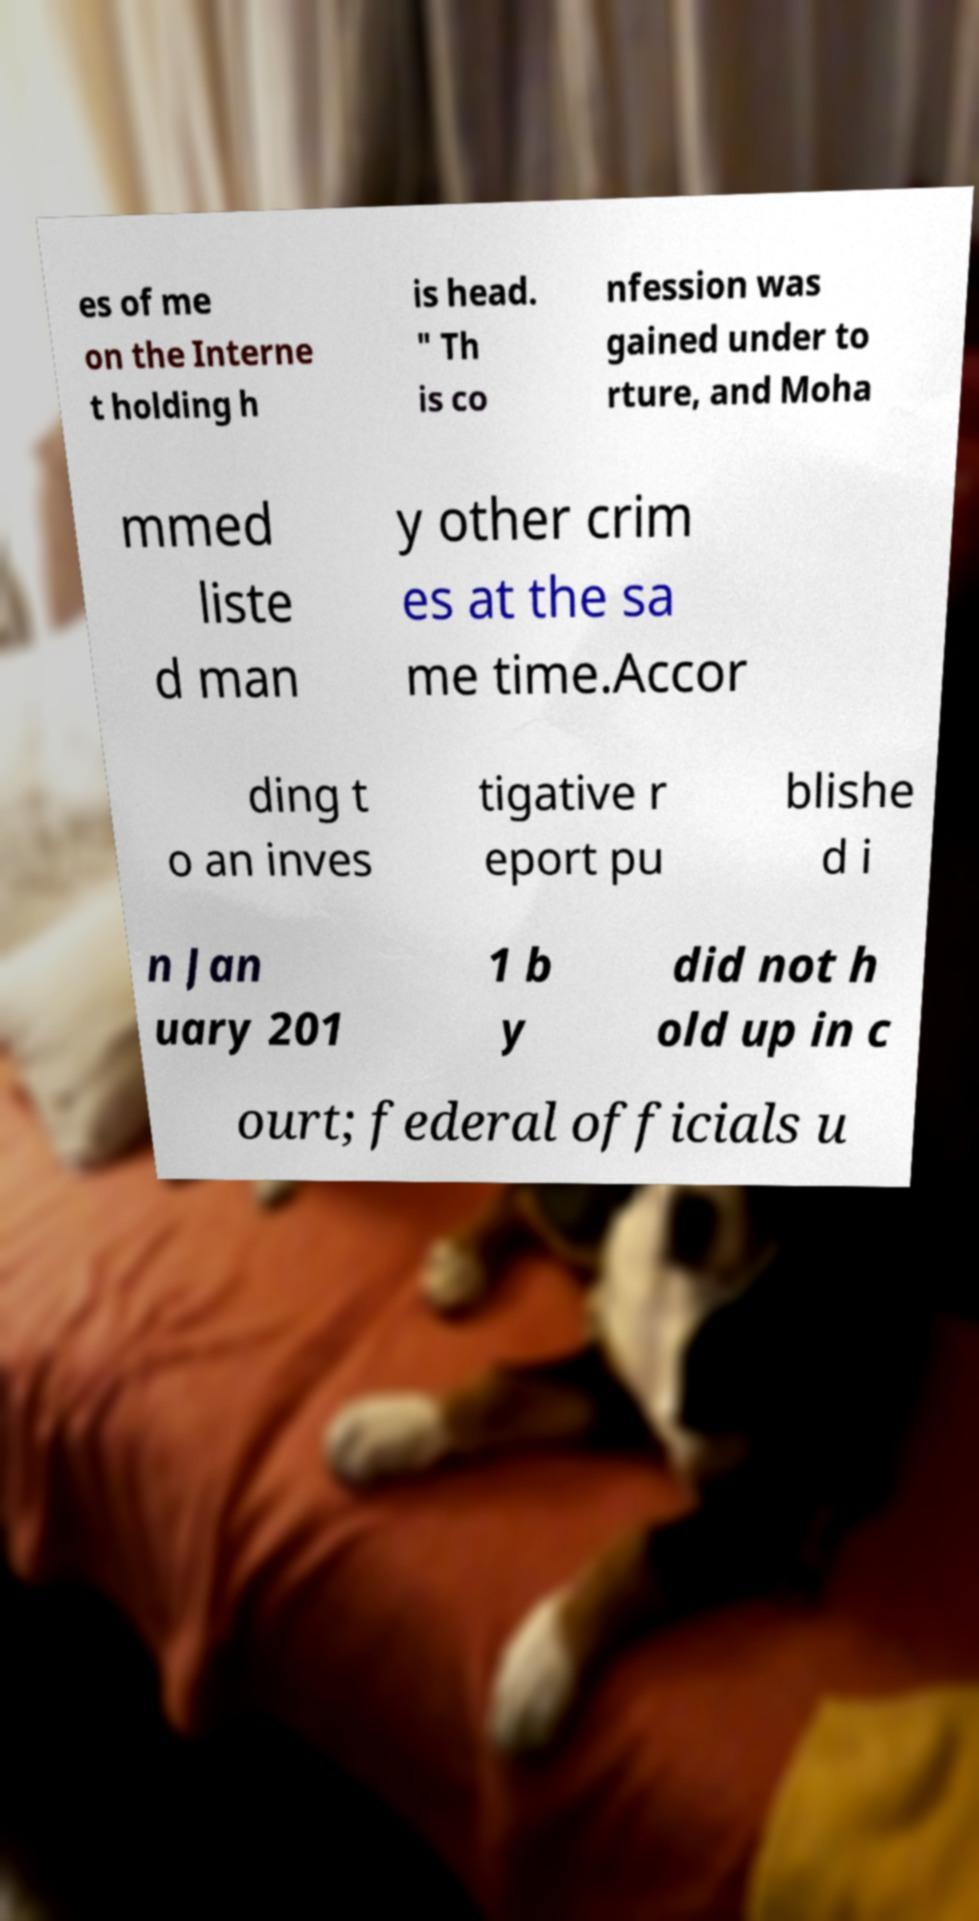What messages or text are displayed in this image? I need them in a readable, typed format. es of me on the Interne t holding h is head. " Th is co nfession was gained under to rture, and Moha mmed liste d man y other crim es at the sa me time.Accor ding t o an inves tigative r eport pu blishe d i n Jan uary 201 1 b y did not h old up in c ourt; federal officials u 